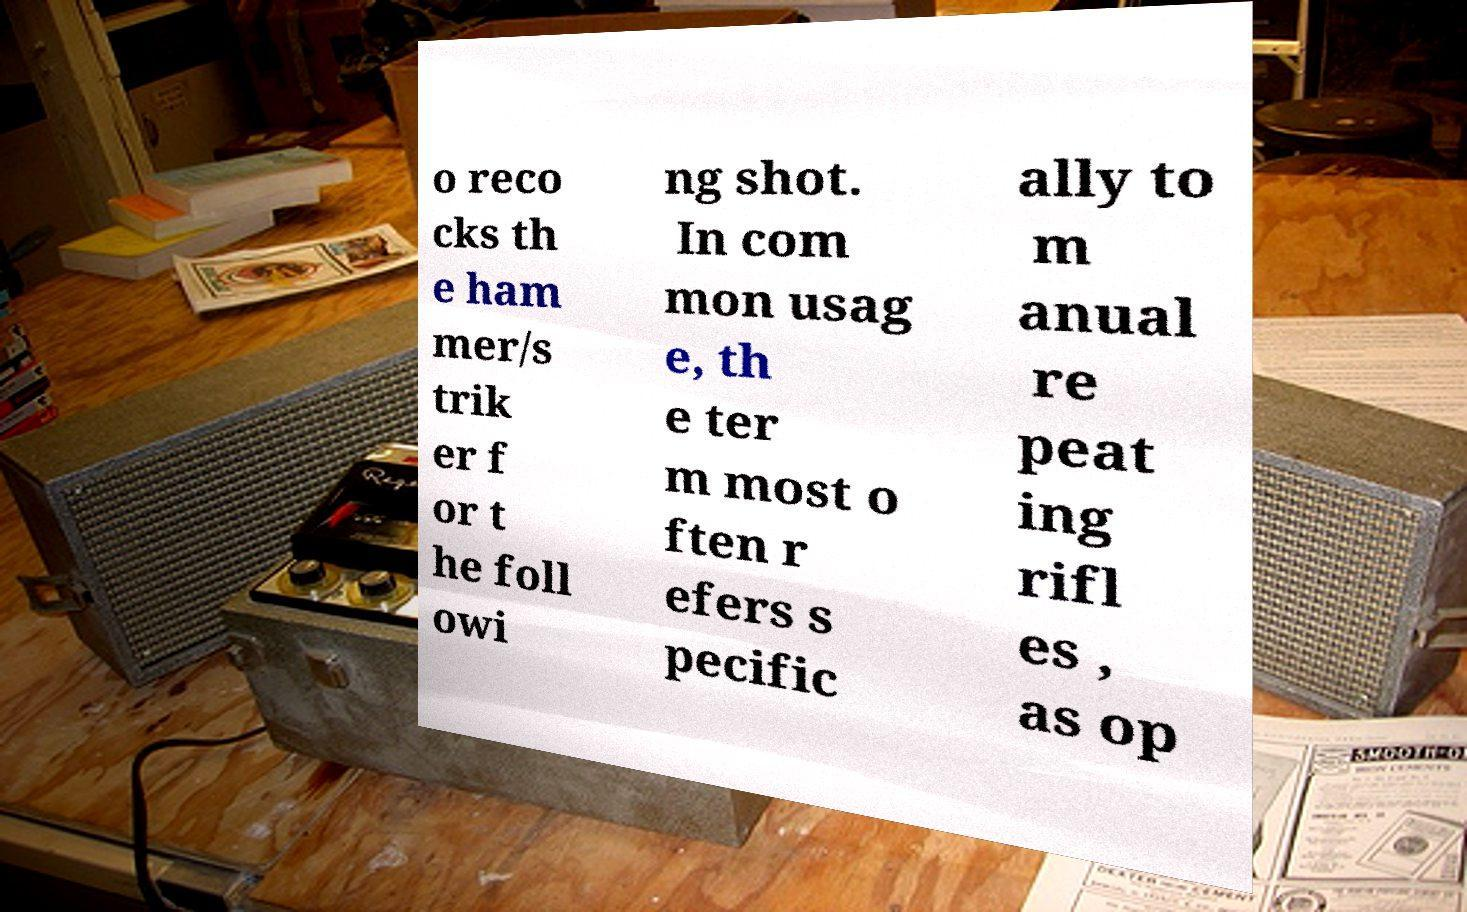Can you read and provide the text displayed in the image?This photo seems to have some interesting text. Can you extract and type it out for me? o reco cks th e ham mer/s trik er f or t he foll owi ng shot. In com mon usag e, th e ter m most o ften r efers s pecific ally to m anual re peat ing rifl es , as op 